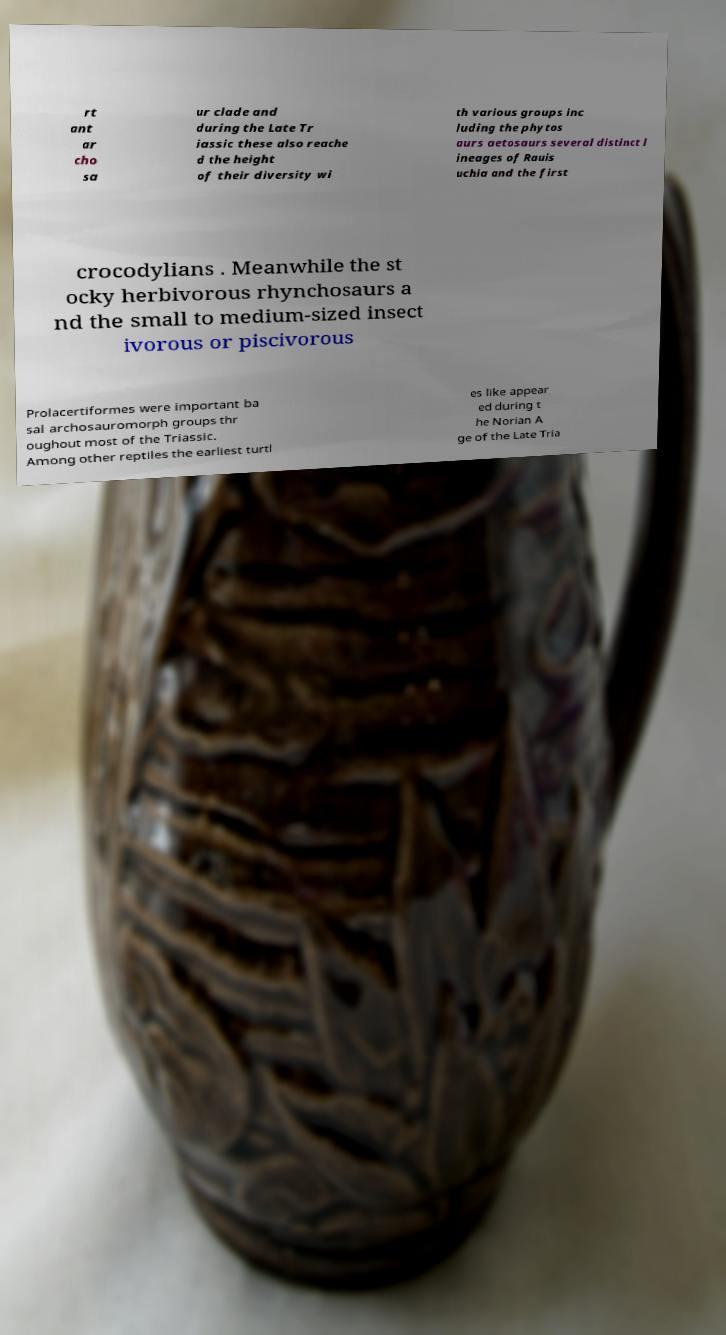Please read and relay the text visible in this image. What does it say? rt ant ar cho sa ur clade and during the Late Tr iassic these also reache d the height of their diversity wi th various groups inc luding the phytos aurs aetosaurs several distinct l ineages of Rauis uchia and the first crocodylians . Meanwhile the st ocky herbivorous rhynchosaurs a nd the small to medium-sized insect ivorous or piscivorous Prolacertiformes were important ba sal archosauromorph groups thr oughout most of the Triassic. Among other reptiles the earliest turtl es like appear ed during t he Norian A ge of the Late Tria 